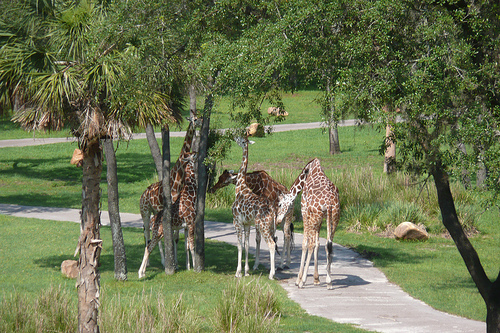What types of trees can be seen in the background? The image features several types of trees, including palm trees and possibly some kind of acacia, which are typical in savannah-like environments where giraffes thrive. 